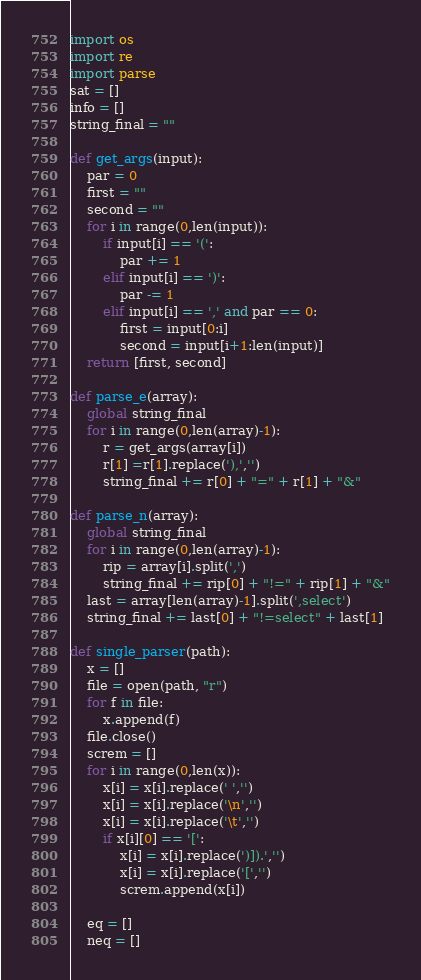Convert code to text. <code><loc_0><loc_0><loc_500><loc_500><_Python_>import os 
import re
import parse
sat = []
info = []
string_final = ""

def get_args(input):
    par = 0
    first = ""
    second = ""
    for i in range(0,len(input)):
        if input[i] == '(':
            par += 1
        elif input[i] == ')':
            par -= 1
        elif input[i] == ',' and par == 0:
            first = input[0:i]
            second = input[i+1:len(input)]
    return [first, second]

def parse_e(array):
    global string_final
    for i in range(0,len(array)-1):
        r = get_args(array[i])
        r[1] =r[1].replace('),','')
        string_final += r[0] + "=" + r[1] + "&"

def parse_n(array):
    global string_final
    for i in range(0,len(array)-1):
        rip = array[i].split(',')
        string_final += rip[0] + "!=" + rip[1] + "&"
    last = array[len(array)-1].split(',select')
    string_final += last[0] + "!=select" + last[1]

def single_parser(path):
    x = []
    file = open(path, "r")
    for f in file:
        x.append(f)
    file.close()
    screm = []
    for i in range(0,len(x)):
        x[i] = x[i].replace(' ','')
        x[i] = x[i].replace('\n','')
        x[i] = x[i].replace('\t','')
        if x[i][0] == '[':
            x[i] = x[i].replace(')]).','')
            x[i] = x[i].replace('[','')
            screm.append(x[i])
    
    eq = []
    neq = []</code> 